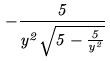<formula> <loc_0><loc_0><loc_500><loc_500>- \frac { 5 } { y ^ { 2 } \sqrt { 5 - \frac { 5 } { y ^ { 2 } } } }</formula> 